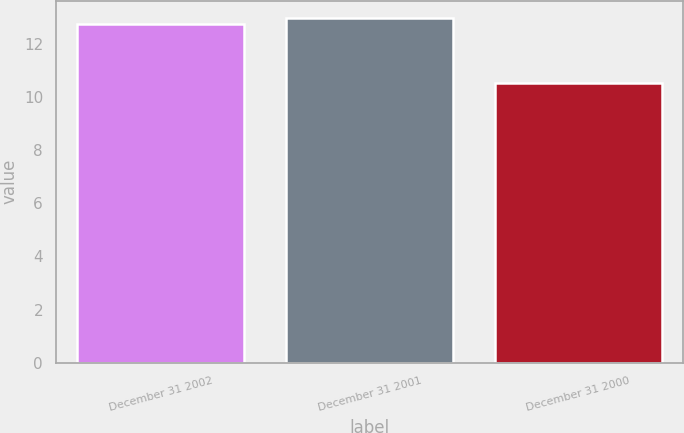<chart> <loc_0><loc_0><loc_500><loc_500><bar_chart><fcel>December 31 2002<fcel>December 31 2001<fcel>December 31 2000<nl><fcel>12.73<fcel>12.96<fcel>10.5<nl></chart> 